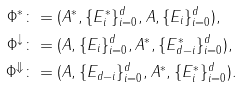<formula> <loc_0><loc_0><loc_500><loc_500>\Phi ^ { * } & \colon = ( A ^ { * } , \{ E ^ { * } _ { i } \} _ { i = 0 } ^ { d } , A , \{ E _ { i } \} _ { i = 0 } ^ { d } ) , \\ \Phi ^ { \downarrow } & \colon = ( A , \{ E _ { i } \} _ { i = 0 } ^ { d } , A ^ { * } , \{ E ^ { * } _ { d - i } \} _ { i = 0 } ^ { d } ) , \\ \Phi ^ { \Downarrow } & \colon = ( A , \{ E _ { d - i } \} _ { i = 0 } ^ { d } , A ^ { * } , \{ E ^ { * } _ { i } \} _ { i = 0 } ^ { d } ) .</formula> 